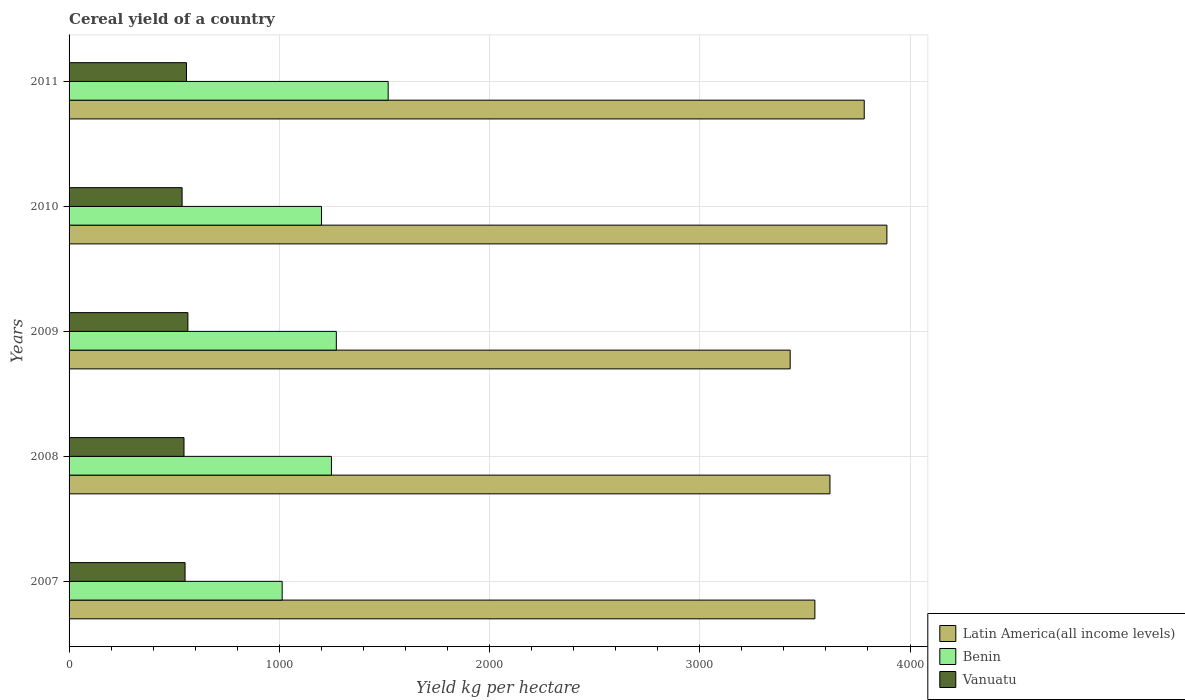How many different coloured bars are there?
Provide a succinct answer. 3. How many groups of bars are there?
Your answer should be compact. 5. Are the number of bars on each tick of the Y-axis equal?
Provide a short and direct response. Yes. How many bars are there on the 3rd tick from the top?
Provide a succinct answer. 3. How many bars are there on the 1st tick from the bottom?
Make the answer very short. 3. What is the total cereal yield in Benin in 2007?
Offer a very short reply. 1013.64. Across all years, what is the maximum total cereal yield in Benin?
Your response must be concise. 1517.77. Across all years, what is the minimum total cereal yield in Vanuatu?
Give a very brief answer. 537.59. In which year was the total cereal yield in Vanuatu maximum?
Your answer should be very brief. 2009. In which year was the total cereal yield in Latin America(all income levels) minimum?
Ensure brevity in your answer.  2009. What is the total total cereal yield in Benin in the graph?
Provide a short and direct response. 6251.15. What is the difference between the total cereal yield in Vanuatu in 2008 and that in 2011?
Keep it short and to the point. -11.82. What is the difference between the total cereal yield in Latin America(all income levels) in 2010 and the total cereal yield in Benin in 2009?
Your response must be concise. 2618.78. What is the average total cereal yield in Vanuatu per year?
Provide a short and direct response. 551.92. In the year 2010, what is the difference between the total cereal yield in Benin and total cereal yield in Latin America(all income levels)?
Make the answer very short. -2689.39. What is the ratio of the total cereal yield in Vanuatu in 2007 to that in 2010?
Give a very brief answer. 1.03. Is the total cereal yield in Latin America(all income levels) in 2007 less than that in 2011?
Ensure brevity in your answer.  Yes. What is the difference between the highest and the second highest total cereal yield in Latin America(all income levels)?
Make the answer very short. 107.78. What is the difference between the highest and the lowest total cereal yield in Latin America(all income levels)?
Keep it short and to the point. 460.05. In how many years, is the total cereal yield in Latin America(all income levels) greater than the average total cereal yield in Latin America(all income levels) taken over all years?
Your answer should be compact. 2. Is the sum of the total cereal yield in Benin in 2008 and 2010 greater than the maximum total cereal yield in Latin America(all income levels) across all years?
Offer a very short reply. No. What does the 1st bar from the top in 2010 represents?
Your answer should be compact. Vanuatu. What does the 3rd bar from the bottom in 2007 represents?
Your answer should be very brief. Vanuatu. Is it the case that in every year, the sum of the total cereal yield in Vanuatu and total cereal yield in Benin is greater than the total cereal yield in Latin America(all income levels)?
Give a very brief answer. No. Are all the bars in the graph horizontal?
Provide a succinct answer. Yes. How many years are there in the graph?
Offer a terse response. 5. Does the graph contain grids?
Offer a very short reply. Yes. What is the title of the graph?
Your answer should be very brief. Cereal yield of a country. Does "High income" appear as one of the legend labels in the graph?
Make the answer very short. No. What is the label or title of the X-axis?
Your answer should be very brief. Yield kg per hectare. What is the label or title of the Y-axis?
Make the answer very short. Years. What is the Yield kg per hectare of Latin America(all income levels) in 2007?
Ensure brevity in your answer.  3547.43. What is the Yield kg per hectare in Benin in 2007?
Keep it short and to the point. 1013.64. What is the Yield kg per hectare in Vanuatu in 2007?
Give a very brief answer. 551.72. What is the Yield kg per hectare in Latin America(all income levels) in 2008?
Make the answer very short. 3619.09. What is the Yield kg per hectare in Benin in 2008?
Provide a short and direct response. 1247.96. What is the Yield kg per hectare of Vanuatu in 2008?
Offer a terse response. 546.67. What is the Yield kg per hectare of Latin America(all income levels) in 2009?
Provide a short and direct response. 3429.92. What is the Yield kg per hectare in Benin in 2009?
Give a very brief answer. 1271.2. What is the Yield kg per hectare of Vanuatu in 2009?
Your answer should be very brief. 565.13. What is the Yield kg per hectare of Latin America(all income levels) in 2010?
Your answer should be very brief. 3889.98. What is the Yield kg per hectare of Benin in 2010?
Make the answer very short. 1200.58. What is the Yield kg per hectare of Vanuatu in 2010?
Make the answer very short. 537.59. What is the Yield kg per hectare of Latin America(all income levels) in 2011?
Make the answer very short. 3782.2. What is the Yield kg per hectare of Benin in 2011?
Provide a short and direct response. 1517.77. What is the Yield kg per hectare of Vanuatu in 2011?
Give a very brief answer. 558.49. Across all years, what is the maximum Yield kg per hectare of Latin America(all income levels)?
Keep it short and to the point. 3889.98. Across all years, what is the maximum Yield kg per hectare in Benin?
Keep it short and to the point. 1517.77. Across all years, what is the maximum Yield kg per hectare of Vanuatu?
Give a very brief answer. 565.13. Across all years, what is the minimum Yield kg per hectare of Latin America(all income levels)?
Give a very brief answer. 3429.92. Across all years, what is the minimum Yield kg per hectare in Benin?
Your answer should be very brief. 1013.64. Across all years, what is the minimum Yield kg per hectare of Vanuatu?
Keep it short and to the point. 537.59. What is the total Yield kg per hectare in Latin America(all income levels) in the graph?
Make the answer very short. 1.83e+04. What is the total Yield kg per hectare in Benin in the graph?
Your response must be concise. 6251.15. What is the total Yield kg per hectare in Vanuatu in the graph?
Ensure brevity in your answer.  2759.6. What is the difference between the Yield kg per hectare of Latin America(all income levels) in 2007 and that in 2008?
Keep it short and to the point. -71.66. What is the difference between the Yield kg per hectare of Benin in 2007 and that in 2008?
Keep it short and to the point. -234.33. What is the difference between the Yield kg per hectare in Vanuatu in 2007 and that in 2008?
Provide a short and direct response. 5.06. What is the difference between the Yield kg per hectare of Latin America(all income levels) in 2007 and that in 2009?
Your answer should be compact. 117.5. What is the difference between the Yield kg per hectare in Benin in 2007 and that in 2009?
Offer a very short reply. -257.56. What is the difference between the Yield kg per hectare in Vanuatu in 2007 and that in 2009?
Your answer should be very brief. -13.41. What is the difference between the Yield kg per hectare in Latin America(all income levels) in 2007 and that in 2010?
Keep it short and to the point. -342.55. What is the difference between the Yield kg per hectare in Benin in 2007 and that in 2010?
Your answer should be compact. -186.94. What is the difference between the Yield kg per hectare in Vanuatu in 2007 and that in 2010?
Your answer should be very brief. 14.13. What is the difference between the Yield kg per hectare in Latin America(all income levels) in 2007 and that in 2011?
Make the answer very short. -234.77. What is the difference between the Yield kg per hectare in Benin in 2007 and that in 2011?
Your answer should be compact. -504.13. What is the difference between the Yield kg per hectare of Vanuatu in 2007 and that in 2011?
Offer a terse response. -6.76. What is the difference between the Yield kg per hectare of Latin America(all income levels) in 2008 and that in 2009?
Give a very brief answer. 189.16. What is the difference between the Yield kg per hectare in Benin in 2008 and that in 2009?
Keep it short and to the point. -23.23. What is the difference between the Yield kg per hectare of Vanuatu in 2008 and that in 2009?
Ensure brevity in your answer.  -18.46. What is the difference between the Yield kg per hectare in Latin America(all income levels) in 2008 and that in 2010?
Provide a short and direct response. -270.89. What is the difference between the Yield kg per hectare of Benin in 2008 and that in 2010?
Offer a terse response. 47.38. What is the difference between the Yield kg per hectare of Vanuatu in 2008 and that in 2010?
Your answer should be very brief. 9.07. What is the difference between the Yield kg per hectare in Latin America(all income levels) in 2008 and that in 2011?
Offer a terse response. -163.11. What is the difference between the Yield kg per hectare of Benin in 2008 and that in 2011?
Make the answer very short. -269.81. What is the difference between the Yield kg per hectare in Vanuatu in 2008 and that in 2011?
Keep it short and to the point. -11.82. What is the difference between the Yield kg per hectare in Latin America(all income levels) in 2009 and that in 2010?
Ensure brevity in your answer.  -460.05. What is the difference between the Yield kg per hectare in Benin in 2009 and that in 2010?
Make the answer very short. 70.62. What is the difference between the Yield kg per hectare in Vanuatu in 2009 and that in 2010?
Your response must be concise. 27.54. What is the difference between the Yield kg per hectare in Latin America(all income levels) in 2009 and that in 2011?
Offer a terse response. -352.27. What is the difference between the Yield kg per hectare of Benin in 2009 and that in 2011?
Provide a succinct answer. -246.57. What is the difference between the Yield kg per hectare in Vanuatu in 2009 and that in 2011?
Offer a terse response. 6.64. What is the difference between the Yield kg per hectare of Latin America(all income levels) in 2010 and that in 2011?
Offer a terse response. 107.78. What is the difference between the Yield kg per hectare of Benin in 2010 and that in 2011?
Make the answer very short. -317.19. What is the difference between the Yield kg per hectare of Vanuatu in 2010 and that in 2011?
Offer a terse response. -20.89. What is the difference between the Yield kg per hectare in Latin America(all income levels) in 2007 and the Yield kg per hectare in Benin in 2008?
Provide a short and direct response. 2299.46. What is the difference between the Yield kg per hectare of Latin America(all income levels) in 2007 and the Yield kg per hectare of Vanuatu in 2008?
Provide a short and direct response. 3000.76. What is the difference between the Yield kg per hectare in Benin in 2007 and the Yield kg per hectare in Vanuatu in 2008?
Provide a short and direct response. 466.97. What is the difference between the Yield kg per hectare in Latin America(all income levels) in 2007 and the Yield kg per hectare in Benin in 2009?
Make the answer very short. 2276.23. What is the difference between the Yield kg per hectare of Latin America(all income levels) in 2007 and the Yield kg per hectare of Vanuatu in 2009?
Make the answer very short. 2982.3. What is the difference between the Yield kg per hectare in Benin in 2007 and the Yield kg per hectare in Vanuatu in 2009?
Make the answer very short. 448.51. What is the difference between the Yield kg per hectare in Latin America(all income levels) in 2007 and the Yield kg per hectare in Benin in 2010?
Keep it short and to the point. 2346.85. What is the difference between the Yield kg per hectare in Latin America(all income levels) in 2007 and the Yield kg per hectare in Vanuatu in 2010?
Offer a very short reply. 3009.83. What is the difference between the Yield kg per hectare in Benin in 2007 and the Yield kg per hectare in Vanuatu in 2010?
Keep it short and to the point. 476.04. What is the difference between the Yield kg per hectare of Latin America(all income levels) in 2007 and the Yield kg per hectare of Benin in 2011?
Provide a short and direct response. 2029.66. What is the difference between the Yield kg per hectare of Latin America(all income levels) in 2007 and the Yield kg per hectare of Vanuatu in 2011?
Offer a very short reply. 2988.94. What is the difference between the Yield kg per hectare of Benin in 2007 and the Yield kg per hectare of Vanuatu in 2011?
Give a very brief answer. 455.15. What is the difference between the Yield kg per hectare in Latin America(all income levels) in 2008 and the Yield kg per hectare in Benin in 2009?
Provide a short and direct response. 2347.89. What is the difference between the Yield kg per hectare in Latin America(all income levels) in 2008 and the Yield kg per hectare in Vanuatu in 2009?
Give a very brief answer. 3053.96. What is the difference between the Yield kg per hectare in Benin in 2008 and the Yield kg per hectare in Vanuatu in 2009?
Make the answer very short. 682.84. What is the difference between the Yield kg per hectare of Latin America(all income levels) in 2008 and the Yield kg per hectare of Benin in 2010?
Your answer should be very brief. 2418.51. What is the difference between the Yield kg per hectare in Latin America(all income levels) in 2008 and the Yield kg per hectare in Vanuatu in 2010?
Provide a short and direct response. 3081.49. What is the difference between the Yield kg per hectare of Benin in 2008 and the Yield kg per hectare of Vanuatu in 2010?
Make the answer very short. 710.37. What is the difference between the Yield kg per hectare of Latin America(all income levels) in 2008 and the Yield kg per hectare of Benin in 2011?
Your answer should be very brief. 2101.32. What is the difference between the Yield kg per hectare of Latin America(all income levels) in 2008 and the Yield kg per hectare of Vanuatu in 2011?
Your response must be concise. 3060.6. What is the difference between the Yield kg per hectare of Benin in 2008 and the Yield kg per hectare of Vanuatu in 2011?
Your answer should be very brief. 689.48. What is the difference between the Yield kg per hectare in Latin America(all income levels) in 2009 and the Yield kg per hectare in Benin in 2010?
Provide a succinct answer. 2229.34. What is the difference between the Yield kg per hectare of Latin America(all income levels) in 2009 and the Yield kg per hectare of Vanuatu in 2010?
Keep it short and to the point. 2892.33. What is the difference between the Yield kg per hectare in Benin in 2009 and the Yield kg per hectare in Vanuatu in 2010?
Provide a succinct answer. 733.6. What is the difference between the Yield kg per hectare of Latin America(all income levels) in 2009 and the Yield kg per hectare of Benin in 2011?
Offer a very short reply. 1912.15. What is the difference between the Yield kg per hectare in Latin America(all income levels) in 2009 and the Yield kg per hectare in Vanuatu in 2011?
Make the answer very short. 2871.44. What is the difference between the Yield kg per hectare of Benin in 2009 and the Yield kg per hectare of Vanuatu in 2011?
Keep it short and to the point. 712.71. What is the difference between the Yield kg per hectare in Latin America(all income levels) in 2010 and the Yield kg per hectare in Benin in 2011?
Give a very brief answer. 2372.2. What is the difference between the Yield kg per hectare of Latin America(all income levels) in 2010 and the Yield kg per hectare of Vanuatu in 2011?
Your response must be concise. 3331.49. What is the difference between the Yield kg per hectare in Benin in 2010 and the Yield kg per hectare in Vanuatu in 2011?
Provide a succinct answer. 642.09. What is the average Yield kg per hectare in Latin America(all income levels) per year?
Provide a short and direct response. 3653.72. What is the average Yield kg per hectare of Benin per year?
Your response must be concise. 1250.23. What is the average Yield kg per hectare of Vanuatu per year?
Make the answer very short. 551.92. In the year 2007, what is the difference between the Yield kg per hectare of Latin America(all income levels) and Yield kg per hectare of Benin?
Keep it short and to the point. 2533.79. In the year 2007, what is the difference between the Yield kg per hectare in Latin America(all income levels) and Yield kg per hectare in Vanuatu?
Provide a succinct answer. 2995.7. In the year 2007, what is the difference between the Yield kg per hectare in Benin and Yield kg per hectare in Vanuatu?
Your answer should be very brief. 461.91. In the year 2008, what is the difference between the Yield kg per hectare in Latin America(all income levels) and Yield kg per hectare in Benin?
Offer a very short reply. 2371.12. In the year 2008, what is the difference between the Yield kg per hectare in Latin America(all income levels) and Yield kg per hectare in Vanuatu?
Provide a succinct answer. 3072.42. In the year 2008, what is the difference between the Yield kg per hectare of Benin and Yield kg per hectare of Vanuatu?
Provide a short and direct response. 701.3. In the year 2009, what is the difference between the Yield kg per hectare of Latin America(all income levels) and Yield kg per hectare of Benin?
Keep it short and to the point. 2158.73. In the year 2009, what is the difference between the Yield kg per hectare in Latin America(all income levels) and Yield kg per hectare in Vanuatu?
Keep it short and to the point. 2864.79. In the year 2009, what is the difference between the Yield kg per hectare of Benin and Yield kg per hectare of Vanuatu?
Your answer should be very brief. 706.07. In the year 2010, what is the difference between the Yield kg per hectare in Latin America(all income levels) and Yield kg per hectare in Benin?
Offer a terse response. 2689.39. In the year 2010, what is the difference between the Yield kg per hectare in Latin America(all income levels) and Yield kg per hectare in Vanuatu?
Provide a succinct answer. 3352.38. In the year 2010, what is the difference between the Yield kg per hectare of Benin and Yield kg per hectare of Vanuatu?
Your response must be concise. 662.99. In the year 2011, what is the difference between the Yield kg per hectare in Latin America(all income levels) and Yield kg per hectare in Benin?
Offer a very short reply. 2264.43. In the year 2011, what is the difference between the Yield kg per hectare in Latin America(all income levels) and Yield kg per hectare in Vanuatu?
Your answer should be very brief. 3223.71. In the year 2011, what is the difference between the Yield kg per hectare of Benin and Yield kg per hectare of Vanuatu?
Give a very brief answer. 959.28. What is the ratio of the Yield kg per hectare in Latin America(all income levels) in 2007 to that in 2008?
Provide a short and direct response. 0.98. What is the ratio of the Yield kg per hectare in Benin in 2007 to that in 2008?
Give a very brief answer. 0.81. What is the ratio of the Yield kg per hectare in Vanuatu in 2007 to that in 2008?
Make the answer very short. 1.01. What is the ratio of the Yield kg per hectare of Latin America(all income levels) in 2007 to that in 2009?
Your response must be concise. 1.03. What is the ratio of the Yield kg per hectare of Benin in 2007 to that in 2009?
Provide a succinct answer. 0.8. What is the ratio of the Yield kg per hectare of Vanuatu in 2007 to that in 2009?
Your response must be concise. 0.98. What is the ratio of the Yield kg per hectare in Latin America(all income levels) in 2007 to that in 2010?
Provide a short and direct response. 0.91. What is the ratio of the Yield kg per hectare of Benin in 2007 to that in 2010?
Ensure brevity in your answer.  0.84. What is the ratio of the Yield kg per hectare of Vanuatu in 2007 to that in 2010?
Keep it short and to the point. 1.03. What is the ratio of the Yield kg per hectare of Latin America(all income levels) in 2007 to that in 2011?
Your answer should be compact. 0.94. What is the ratio of the Yield kg per hectare in Benin in 2007 to that in 2011?
Your response must be concise. 0.67. What is the ratio of the Yield kg per hectare in Vanuatu in 2007 to that in 2011?
Your response must be concise. 0.99. What is the ratio of the Yield kg per hectare in Latin America(all income levels) in 2008 to that in 2009?
Your response must be concise. 1.06. What is the ratio of the Yield kg per hectare of Benin in 2008 to that in 2009?
Your answer should be very brief. 0.98. What is the ratio of the Yield kg per hectare in Vanuatu in 2008 to that in 2009?
Your answer should be very brief. 0.97. What is the ratio of the Yield kg per hectare in Latin America(all income levels) in 2008 to that in 2010?
Give a very brief answer. 0.93. What is the ratio of the Yield kg per hectare in Benin in 2008 to that in 2010?
Your answer should be very brief. 1.04. What is the ratio of the Yield kg per hectare of Vanuatu in 2008 to that in 2010?
Give a very brief answer. 1.02. What is the ratio of the Yield kg per hectare in Latin America(all income levels) in 2008 to that in 2011?
Offer a very short reply. 0.96. What is the ratio of the Yield kg per hectare of Benin in 2008 to that in 2011?
Your response must be concise. 0.82. What is the ratio of the Yield kg per hectare in Vanuatu in 2008 to that in 2011?
Your answer should be compact. 0.98. What is the ratio of the Yield kg per hectare of Latin America(all income levels) in 2009 to that in 2010?
Keep it short and to the point. 0.88. What is the ratio of the Yield kg per hectare in Benin in 2009 to that in 2010?
Keep it short and to the point. 1.06. What is the ratio of the Yield kg per hectare of Vanuatu in 2009 to that in 2010?
Offer a very short reply. 1.05. What is the ratio of the Yield kg per hectare in Latin America(all income levels) in 2009 to that in 2011?
Make the answer very short. 0.91. What is the ratio of the Yield kg per hectare of Benin in 2009 to that in 2011?
Ensure brevity in your answer.  0.84. What is the ratio of the Yield kg per hectare in Vanuatu in 2009 to that in 2011?
Offer a terse response. 1.01. What is the ratio of the Yield kg per hectare of Latin America(all income levels) in 2010 to that in 2011?
Offer a terse response. 1.03. What is the ratio of the Yield kg per hectare of Benin in 2010 to that in 2011?
Your answer should be very brief. 0.79. What is the ratio of the Yield kg per hectare of Vanuatu in 2010 to that in 2011?
Give a very brief answer. 0.96. What is the difference between the highest and the second highest Yield kg per hectare of Latin America(all income levels)?
Your answer should be very brief. 107.78. What is the difference between the highest and the second highest Yield kg per hectare of Benin?
Your answer should be compact. 246.57. What is the difference between the highest and the second highest Yield kg per hectare in Vanuatu?
Offer a terse response. 6.64. What is the difference between the highest and the lowest Yield kg per hectare in Latin America(all income levels)?
Give a very brief answer. 460.05. What is the difference between the highest and the lowest Yield kg per hectare in Benin?
Ensure brevity in your answer.  504.13. What is the difference between the highest and the lowest Yield kg per hectare of Vanuatu?
Offer a very short reply. 27.54. 